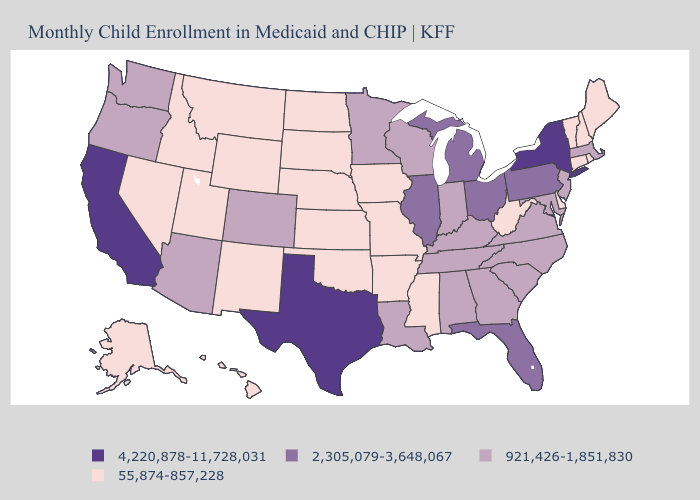Does Georgia have a lower value than Massachusetts?
Give a very brief answer. No. Name the states that have a value in the range 55,874-857,228?
Be succinct. Alaska, Arkansas, Connecticut, Delaware, Hawaii, Idaho, Iowa, Kansas, Maine, Mississippi, Missouri, Montana, Nebraska, Nevada, New Hampshire, New Mexico, North Dakota, Oklahoma, Rhode Island, South Dakota, Utah, Vermont, West Virginia, Wyoming. Among the states that border Georgia , which have the highest value?
Short answer required. Florida. Which states have the lowest value in the USA?
Answer briefly. Alaska, Arkansas, Connecticut, Delaware, Hawaii, Idaho, Iowa, Kansas, Maine, Mississippi, Missouri, Montana, Nebraska, Nevada, New Hampshire, New Mexico, North Dakota, Oklahoma, Rhode Island, South Dakota, Utah, Vermont, West Virginia, Wyoming. Does Wisconsin have the same value as California?
Short answer required. No. How many symbols are there in the legend?
Give a very brief answer. 4. What is the value of Mississippi?
Give a very brief answer. 55,874-857,228. Does the first symbol in the legend represent the smallest category?
Give a very brief answer. No. What is the value of Hawaii?
Be succinct. 55,874-857,228. What is the lowest value in the South?
Give a very brief answer. 55,874-857,228. What is the value of North Dakota?
Give a very brief answer. 55,874-857,228. Does the first symbol in the legend represent the smallest category?
Keep it brief. No. What is the value of Alaska?
Be succinct. 55,874-857,228. Among the states that border Connecticut , which have the highest value?
Quick response, please. New York. 